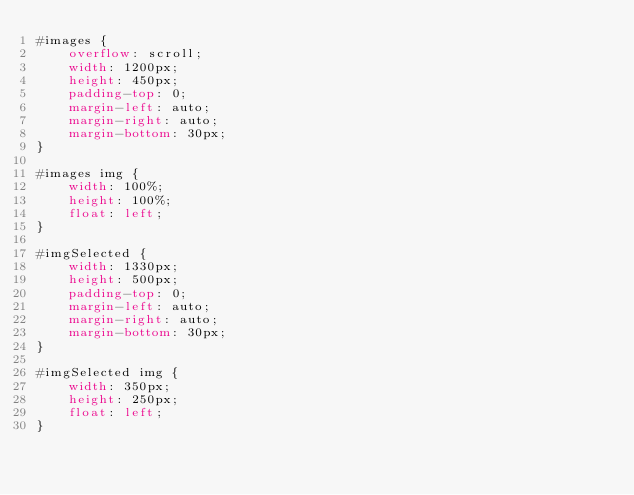<code> <loc_0><loc_0><loc_500><loc_500><_CSS_>#images {
    overflow: scroll;
    width: 1200px;
    height: 450px;
    padding-top: 0;
    margin-left: auto;
    margin-right: auto;
    margin-bottom: 30px;
}

#images img {
    width: 100%;
    height: 100%;
    float: left;
}

#imgSelected {
    width: 1330px;
    height: 500px;
    padding-top: 0;
    margin-left: auto;
    margin-right: auto;
    margin-bottom: 30px;
}

#imgSelected img {
    width: 350px;
    height: 250px;
    float: left;
}</code> 